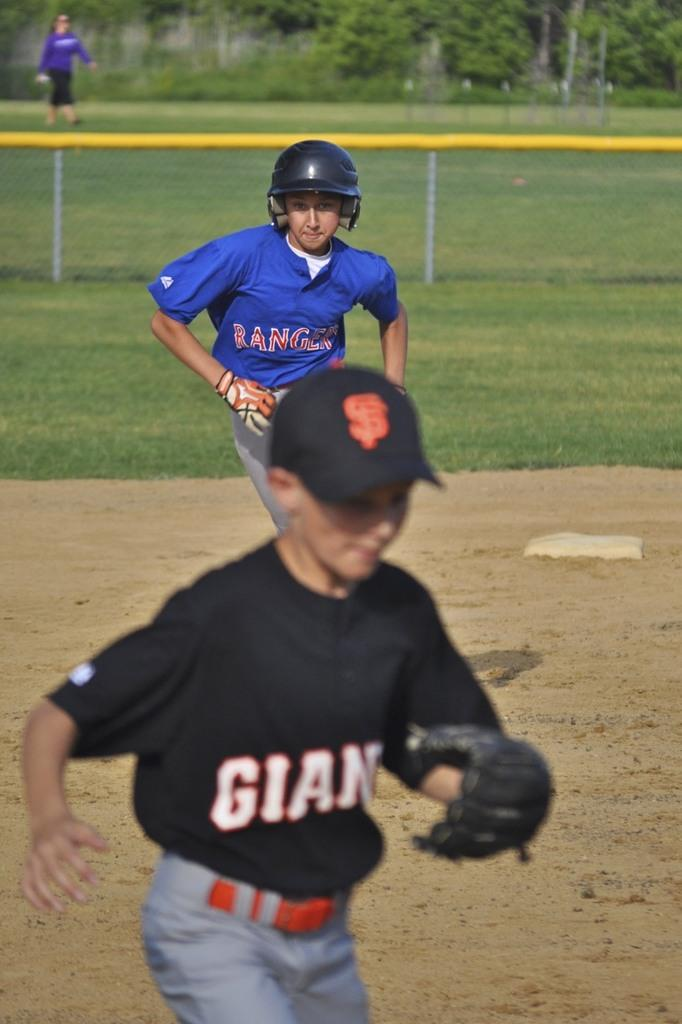Provide a one-sentence caption for the provided image. A baseball game between the Rangers and the Giants. 